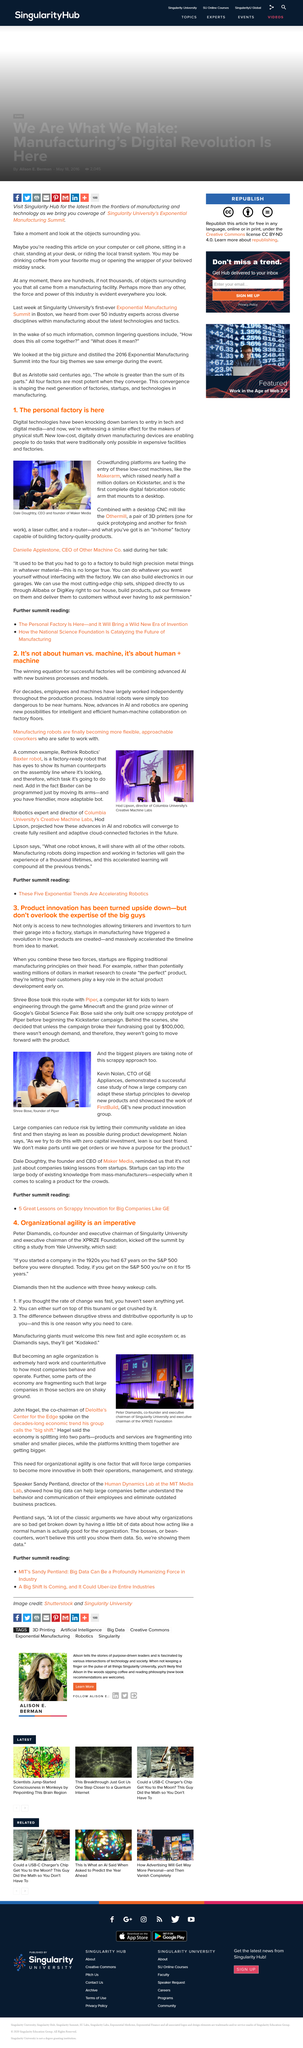Point out several critical features in this image. Shree Bose created Piper. Makerarm raised nearly half a million dollars on Kickstarter. The use of new technologies in factories allows tinkerers to transform their garages into factories by enabling them to produce goods and services with greater efficiency and flexibility. I possess the necessary tools to craft high-quality products with precision and accuracy, utilizing a desktop CNC mill, two 3D printers, a laser cutter, and a router. The article references a type of wave that is a tsunami. 